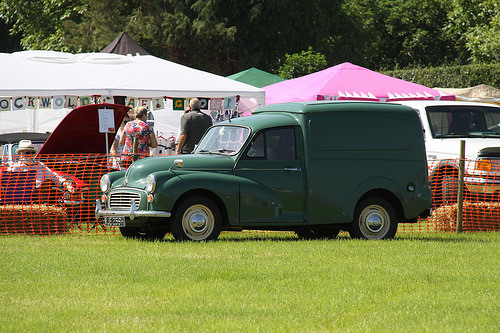<image>
Can you confirm if the car is on the grass? Yes. Looking at the image, I can see the car is positioned on top of the grass, with the grass providing support. Is the car next to the women? No. The car is not positioned next to the women. They are located in different areas of the scene. Is there a truck in front of the tent? Yes. The truck is positioned in front of the tent, appearing closer to the camera viewpoint. 